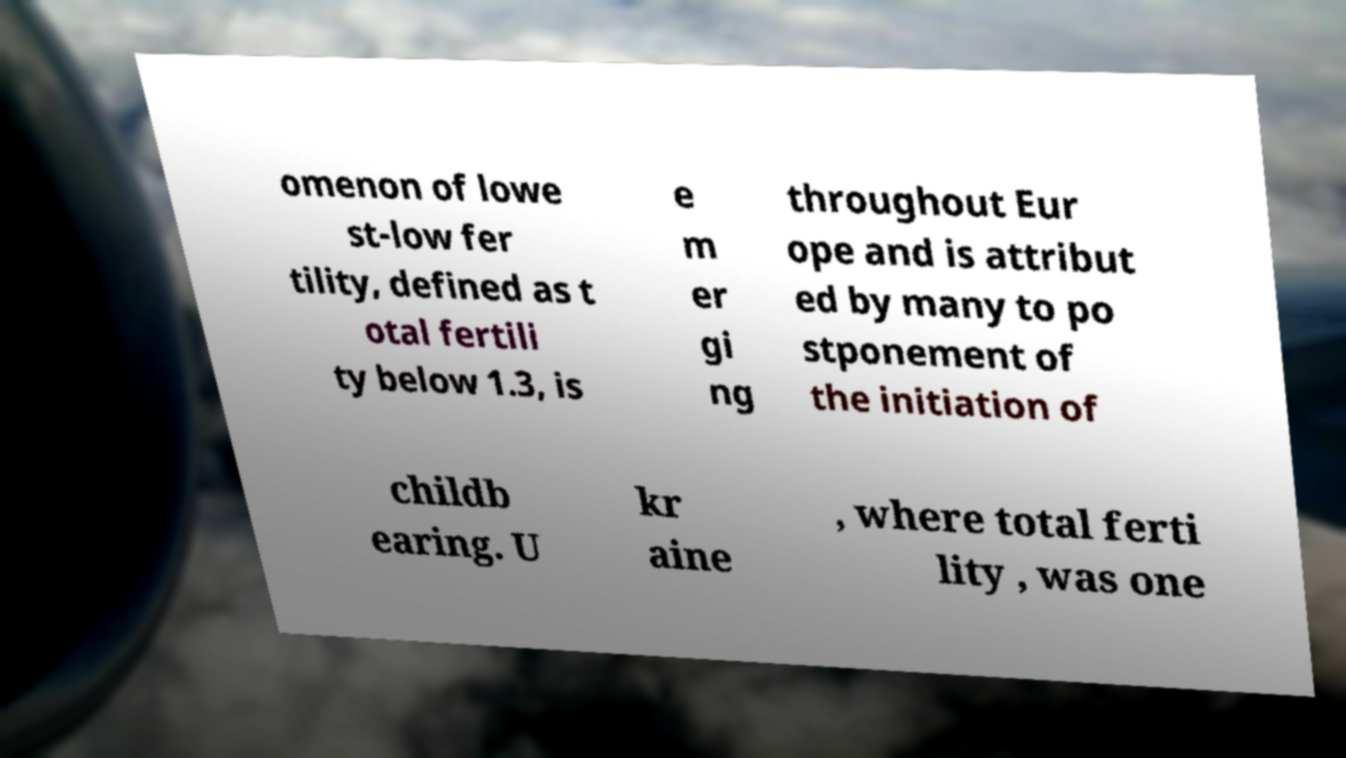There's text embedded in this image that I need extracted. Can you transcribe it verbatim? omenon of lowe st-low fer tility, defined as t otal fertili ty below 1.3, is e m er gi ng throughout Eur ope and is attribut ed by many to po stponement of the initiation of childb earing. U kr aine , where total ferti lity , was one 